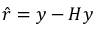<formula> <loc_0><loc_0><loc_500><loc_500>{ \hat { r } } = y - H y</formula> 